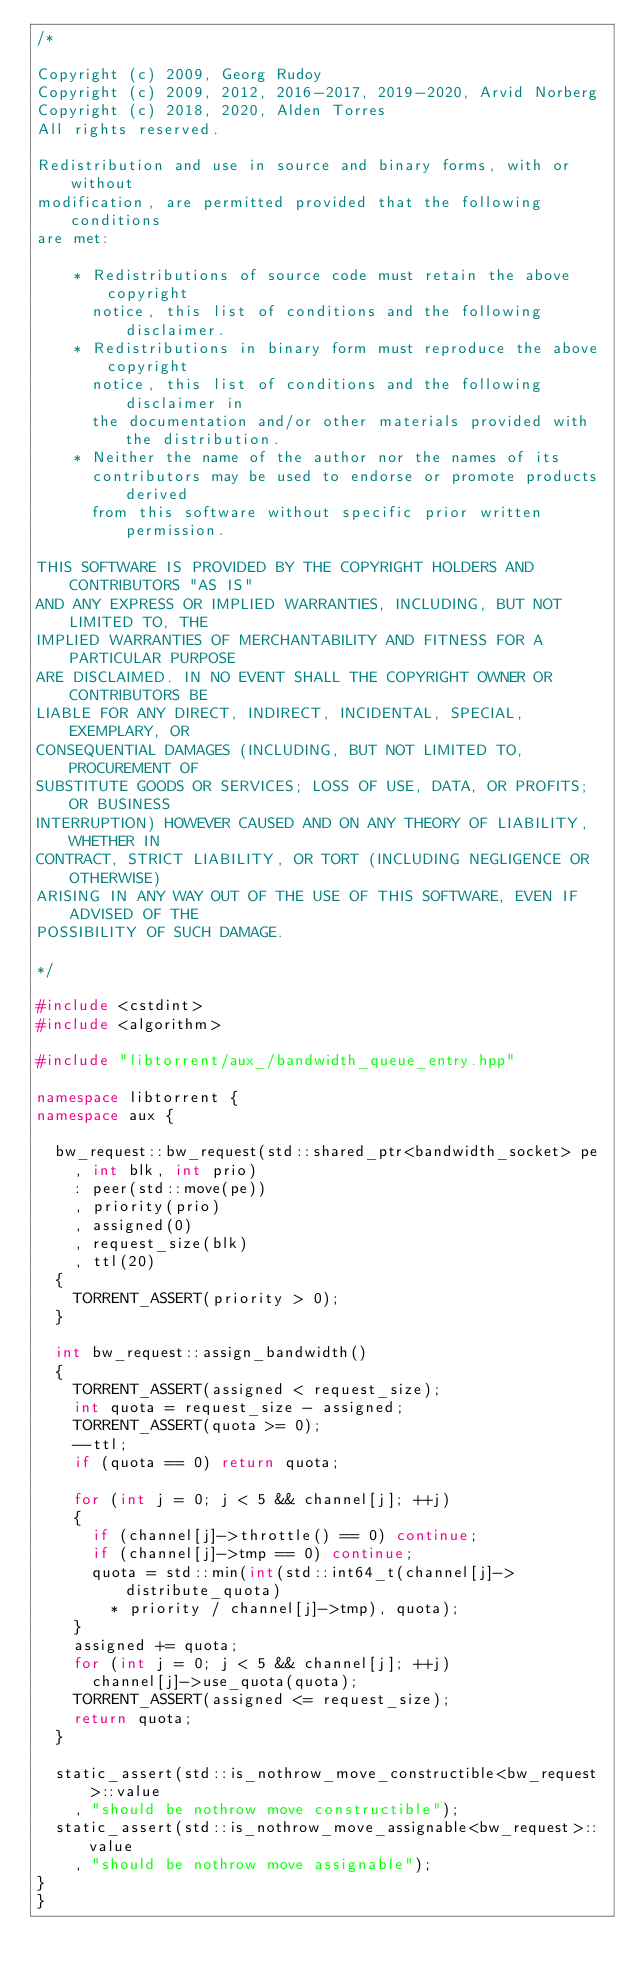<code> <loc_0><loc_0><loc_500><loc_500><_C++_>/*

Copyright (c) 2009, Georg Rudoy
Copyright (c) 2009, 2012, 2016-2017, 2019-2020, Arvid Norberg
Copyright (c) 2018, 2020, Alden Torres
All rights reserved.

Redistribution and use in source and binary forms, with or without
modification, are permitted provided that the following conditions
are met:

    * Redistributions of source code must retain the above copyright
      notice, this list of conditions and the following disclaimer.
    * Redistributions in binary form must reproduce the above copyright
      notice, this list of conditions and the following disclaimer in
      the documentation and/or other materials provided with the distribution.
    * Neither the name of the author nor the names of its
      contributors may be used to endorse or promote products derived
      from this software without specific prior written permission.

THIS SOFTWARE IS PROVIDED BY THE COPYRIGHT HOLDERS AND CONTRIBUTORS "AS IS"
AND ANY EXPRESS OR IMPLIED WARRANTIES, INCLUDING, BUT NOT LIMITED TO, THE
IMPLIED WARRANTIES OF MERCHANTABILITY AND FITNESS FOR A PARTICULAR PURPOSE
ARE DISCLAIMED. IN NO EVENT SHALL THE COPYRIGHT OWNER OR CONTRIBUTORS BE
LIABLE FOR ANY DIRECT, INDIRECT, INCIDENTAL, SPECIAL, EXEMPLARY, OR
CONSEQUENTIAL DAMAGES (INCLUDING, BUT NOT LIMITED TO, PROCUREMENT OF
SUBSTITUTE GOODS OR SERVICES; LOSS OF USE, DATA, OR PROFITS; OR BUSINESS
INTERRUPTION) HOWEVER CAUSED AND ON ANY THEORY OF LIABILITY, WHETHER IN
CONTRACT, STRICT LIABILITY, OR TORT (INCLUDING NEGLIGENCE OR OTHERWISE)
ARISING IN ANY WAY OUT OF THE USE OF THIS SOFTWARE, EVEN IF ADVISED OF THE
POSSIBILITY OF SUCH DAMAGE.

*/

#include <cstdint>
#include <algorithm>

#include "libtorrent/aux_/bandwidth_queue_entry.hpp"

namespace libtorrent {
namespace aux {

	bw_request::bw_request(std::shared_ptr<bandwidth_socket> pe
		, int blk, int prio)
		: peer(std::move(pe))
		, priority(prio)
		, assigned(0)
		, request_size(blk)
		, ttl(20)
	{
		TORRENT_ASSERT(priority > 0);
	}

	int bw_request::assign_bandwidth()
	{
		TORRENT_ASSERT(assigned < request_size);
		int quota = request_size - assigned;
		TORRENT_ASSERT(quota >= 0);
		--ttl;
		if (quota == 0) return quota;

		for (int j = 0; j < 5 && channel[j]; ++j)
		{
			if (channel[j]->throttle() == 0) continue;
			if (channel[j]->tmp == 0) continue;
			quota = std::min(int(std::int64_t(channel[j]->distribute_quota)
				* priority / channel[j]->tmp), quota);
		}
		assigned += quota;
		for (int j = 0; j < 5 && channel[j]; ++j)
			channel[j]->use_quota(quota);
		TORRENT_ASSERT(assigned <= request_size);
		return quota;
	}

	static_assert(std::is_nothrow_move_constructible<bw_request>::value
		, "should be nothrow move constructible");
	static_assert(std::is_nothrow_move_assignable<bw_request>::value
		, "should be nothrow move assignable");
}
}
</code> 